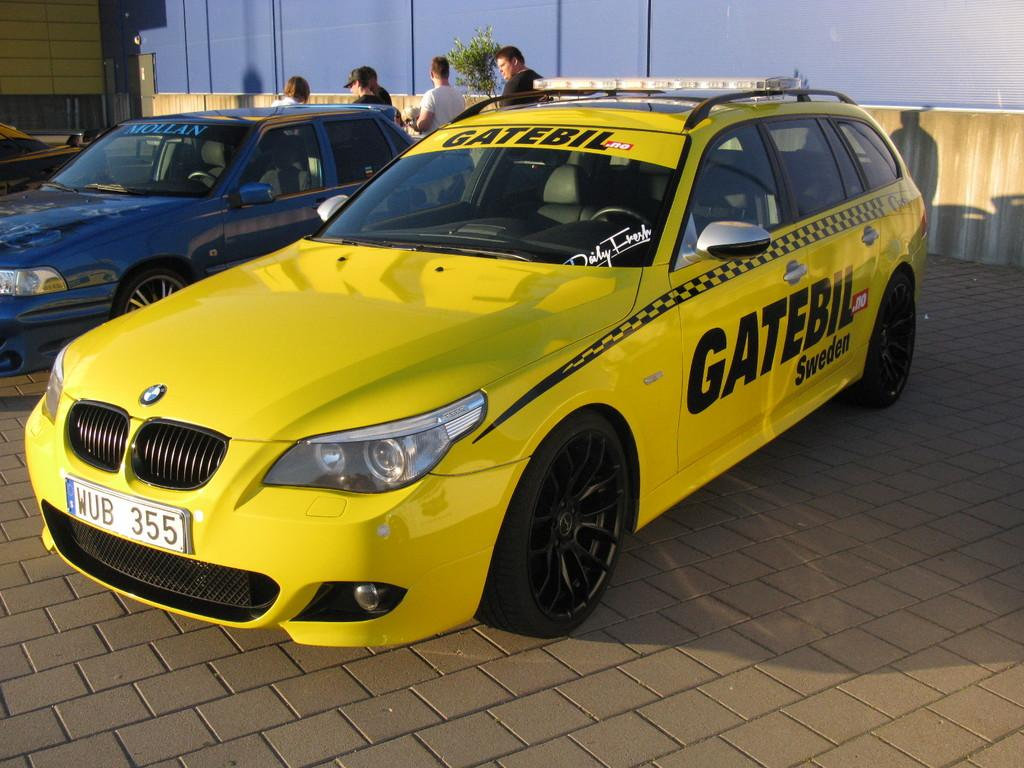<image>
Write a terse but informative summary of the picture. a Gate car that is yellow in color 